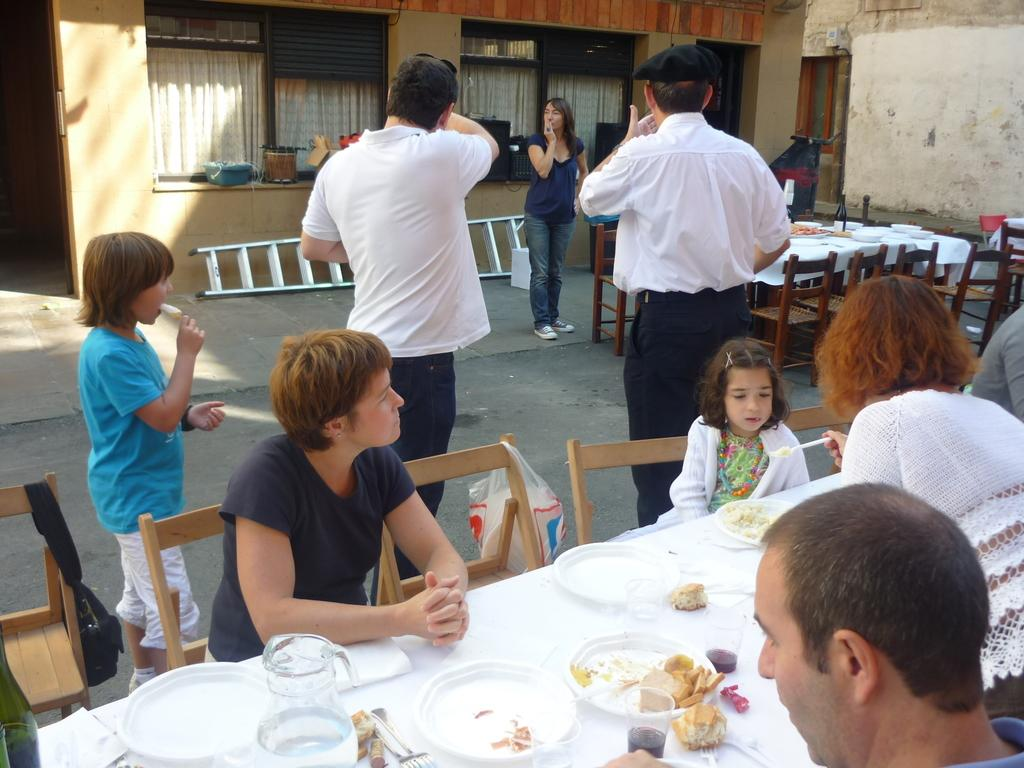What are the people in the image doing on the road? The people standing on the road are not performing any specific action in the image. What are the people doing around the dining table? The people sitting at the dining table are eating food. What is the location of the building in the image? The building is behind the dining table. What type of lawyer is sitting at the dining table in the image? There is no lawyer present in the image; it only shows people eating food around a dining table. What is the engine used for in the image? There is no engine present in the image. 